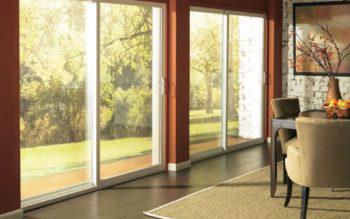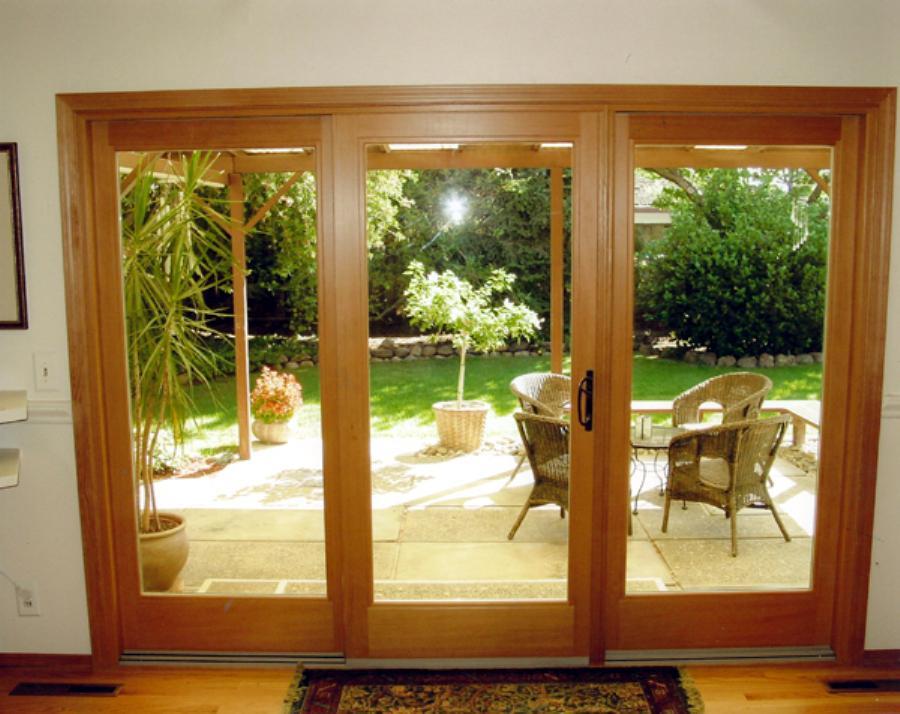The first image is the image on the left, the second image is the image on the right. For the images shown, is this caption "There is only one chair near the door in the right image." true? Answer yes or no. No. 